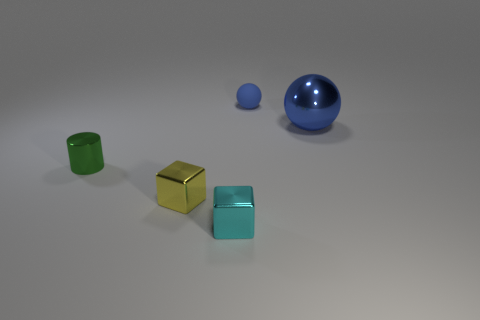Add 1 matte spheres. How many objects exist? 6 Subtract all cyan cubes. How many cubes are left? 1 Subtract 1 spheres. How many spheres are left? 1 Subtract all cylinders. How many objects are left? 4 Subtract all brown blocks. Subtract all yellow spheres. How many blocks are left? 2 Add 1 small things. How many small things are left? 5 Add 5 small blue rubber cylinders. How many small blue rubber cylinders exist? 5 Subtract 0 cyan spheres. How many objects are left? 5 Subtract all big shiny spheres. Subtract all shiny things. How many objects are left? 0 